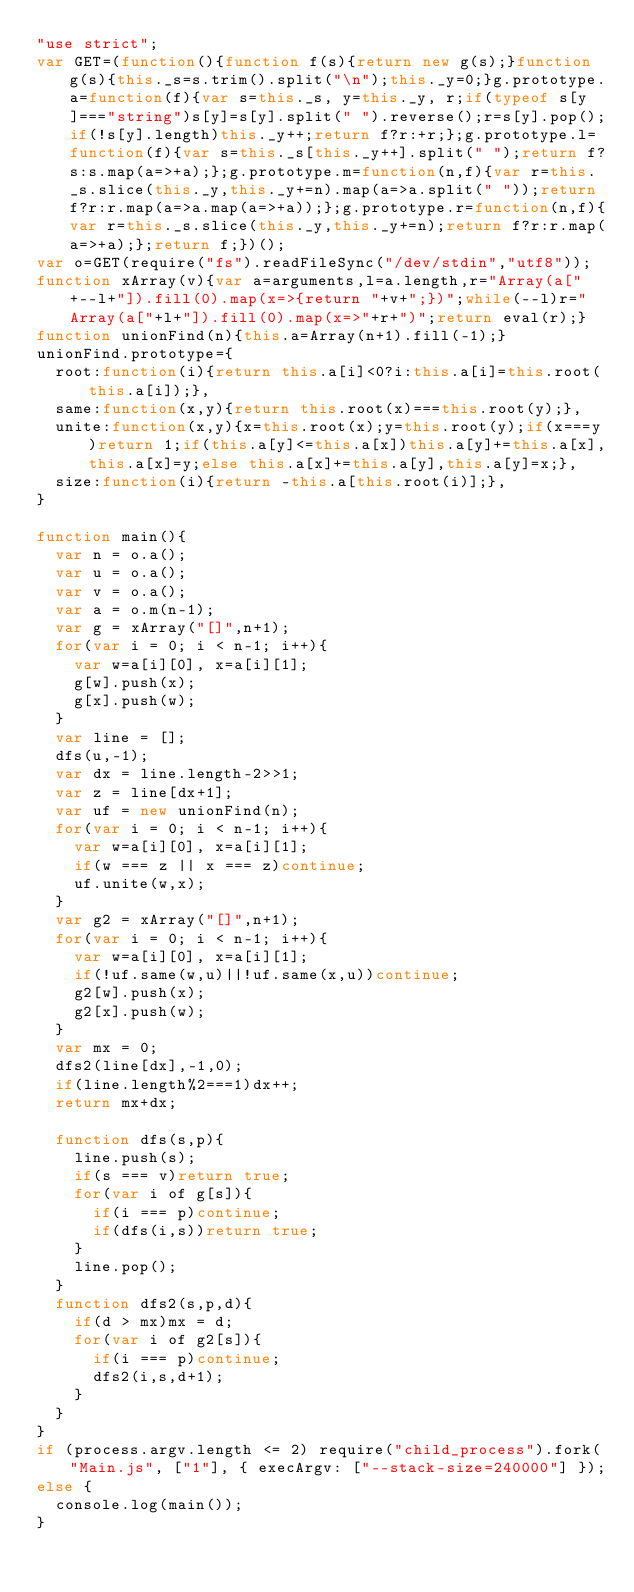Convert code to text. <code><loc_0><loc_0><loc_500><loc_500><_JavaScript_>"use strict";
var GET=(function(){function f(s){return new g(s);}function g(s){this._s=s.trim().split("\n");this._y=0;}g.prototype.a=function(f){var s=this._s, y=this._y, r;if(typeof s[y]==="string")s[y]=s[y].split(" ").reverse();r=s[y].pop();if(!s[y].length)this._y++;return f?r:+r;};g.prototype.l=function(f){var s=this._s[this._y++].split(" ");return f?s:s.map(a=>+a);};g.prototype.m=function(n,f){var r=this._s.slice(this._y,this._y+=n).map(a=>a.split(" "));return f?r:r.map(a=>a.map(a=>+a));};g.prototype.r=function(n,f){var r=this._s.slice(this._y,this._y+=n);return f?r:r.map(a=>+a);};return f;})();
var o=GET(require("fs").readFileSync("/dev/stdin","utf8"));
function xArray(v){var a=arguments,l=a.length,r="Array(a["+--l+"]).fill(0).map(x=>{return "+v+";})";while(--l)r="Array(a["+l+"]).fill(0).map(x=>"+r+")";return eval(r);}
function unionFind(n){this.a=Array(n+1).fill(-1);}
unionFind.prototype={
  root:function(i){return this.a[i]<0?i:this.a[i]=this.root(this.a[i]);},
  same:function(x,y){return this.root(x)===this.root(y);},
  unite:function(x,y){x=this.root(x);y=this.root(y);if(x===y)return 1;if(this.a[y]<=this.a[x])this.a[y]+=this.a[x],this.a[x]=y;else this.a[x]+=this.a[y],this.a[y]=x;},
  size:function(i){return -this.a[this.root(i)];},
}

function main(){
  var n = o.a();
  var u = o.a();
  var v = o.a();
  var a = o.m(n-1);
  var g = xArray("[]",n+1);
  for(var i = 0; i < n-1; i++){
    var w=a[i][0], x=a[i][1];
    g[w].push(x);
    g[x].push(w);
  }
  var line = [];
  dfs(u,-1);
  var dx = line.length-2>>1;
  var z = line[dx+1];
  var uf = new unionFind(n);
  for(var i = 0; i < n-1; i++){
    var w=a[i][0], x=a[i][1];
    if(w === z || x === z)continue;
    uf.unite(w,x);
  }
  var g2 = xArray("[]",n+1);
  for(var i = 0; i < n-1; i++){
    var w=a[i][0], x=a[i][1];
    if(!uf.same(w,u)||!uf.same(x,u))continue;
    g2[w].push(x);
    g2[x].push(w);
  }
  var mx = 0;
  dfs2(line[dx],-1,0);
  if(line.length%2===1)dx++;
  return mx+dx;

  function dfs(s,p){
    line.push(s);
    if(s === v)return true;
    for(var i of g[s]){
      if(i === p)continue;
      if(dfs(i,s))return true;
    }
    line.pop();
  }
  function dfs2(s,p,d){
    if(d > mx)mx = d;
    for(var i of g2[s]){
      if(i === p)continue;
      dfs2(i,s,d+1);
    }
  }
}
if (process.argv.length <= 2) require("child_process").fork("Main.js", ["1"], { execArgv: ["--stack-size=240000"] });
else {
  console.log(main());
}</code> 